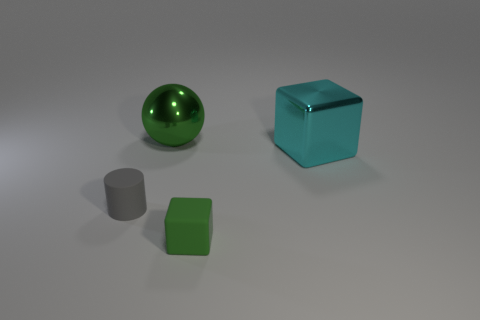Are any big brown metal spheres visible?
Offer a very short reply. No. What shape is the object that is behind the tiny gray rubber cylinder and in front of the metal sphere?
Your answer should be compact. Cube. What is the size of the green object that is behind the tiny gray cylinder?
Your answer should be compact. Large. There is a object right of the tiny rubber block; is it the same color as the rubber block?
Your answer should be compact. No. What number of other tiny cyan things are the same shape as the cyan object?
Give a very brief answer. 0. How many things are either green things behind the tiny green matte thing or large things that are behind the big cyan metallic thing?
Make the answer very short. 1. How many brown objects are big objects or rubber cylinders?
Provide a short and direct response. 0. The object that is on the right side of the green sphere and in front of the cyan thing is made of what material?
Keep it short and to the point. Rubber. Are the gray cylinder and the green cube made of the same material?
Your response must be concise. Yes. What number of green balls have the same size as the metal cube?
Ensure brevity in your answer.  1. 